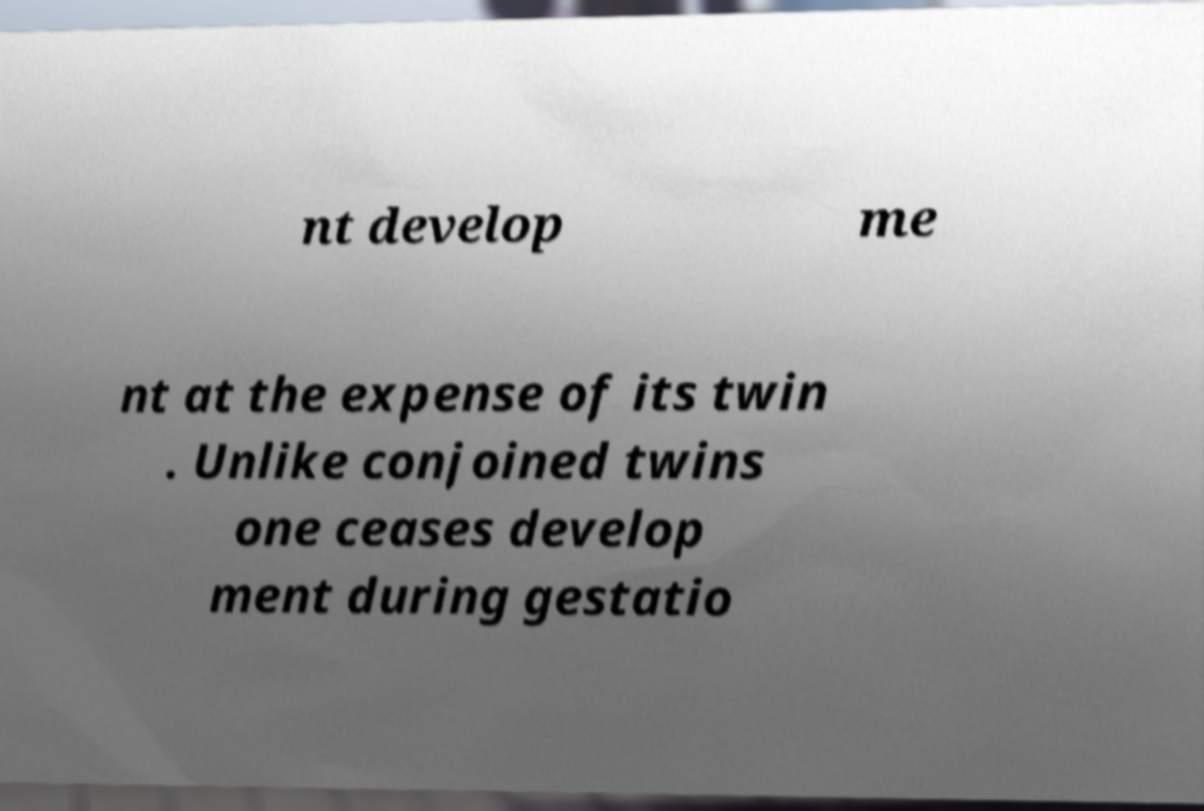Could you extract and type out the text from this image? nt develop me nt at the expense of its twin . Unlike conjoined twins one ceases develop ment during gestatio 